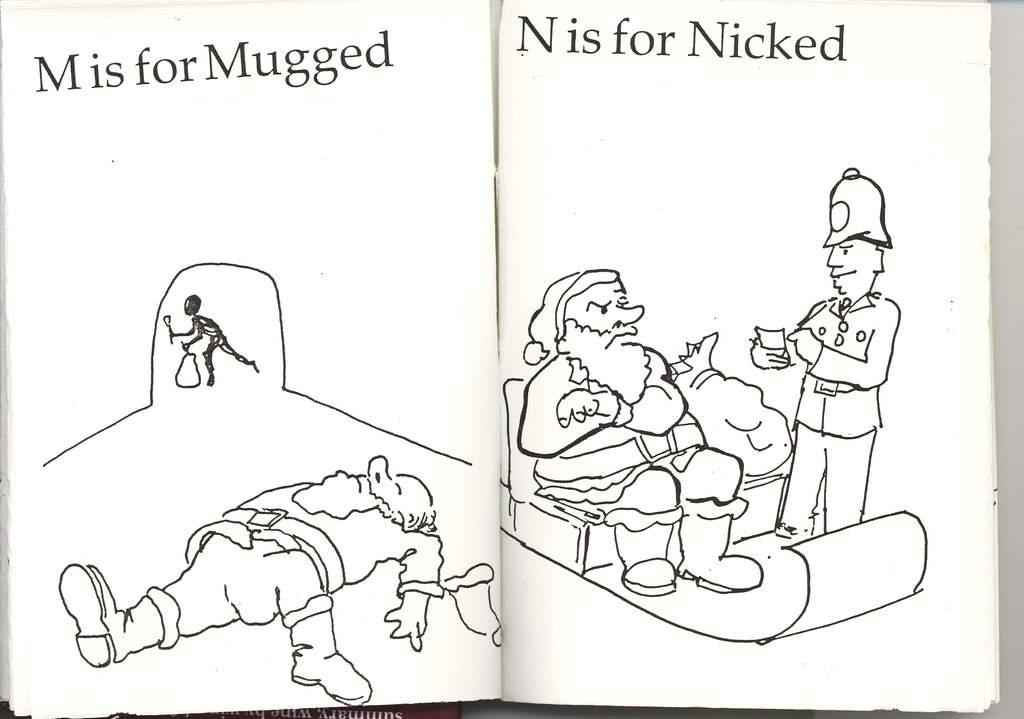How many people are present in the image? There are four persons in the image. What can be seen in the image that people might sit on? There are chairs in the image. What else is visible in the image besides the people and chairs? There are objects and text in the image. Can you tell me how many drawers are visible in the image? There is no mention of drawers in the provided facts, so it cannot be determined if any are visible in the image. 